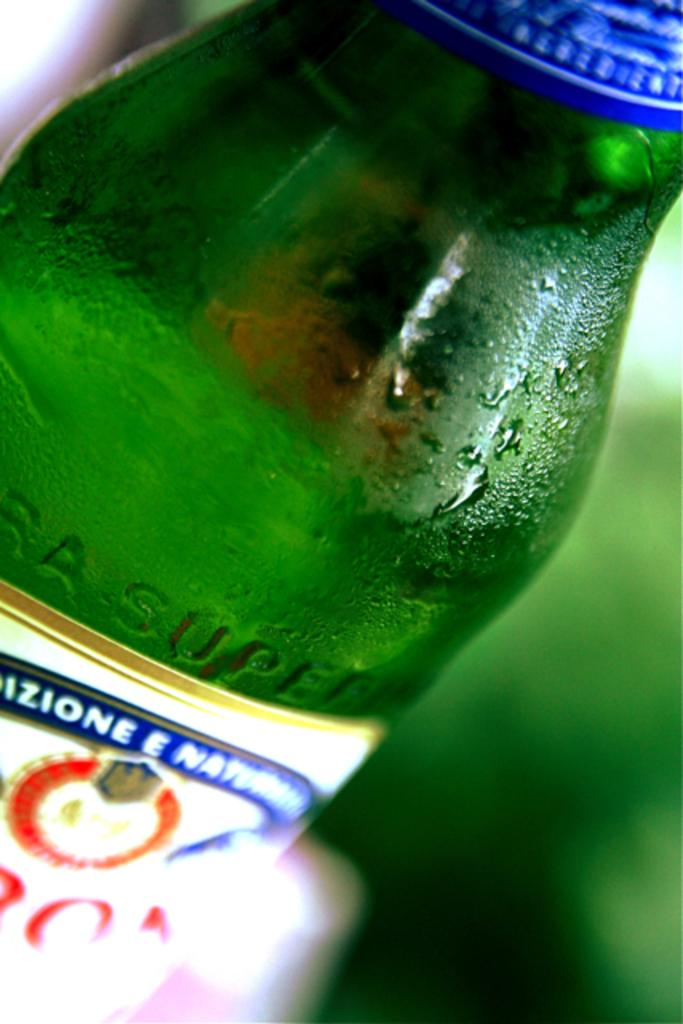What object can be seen in the image? There is a bottle in the image. How many trees are visible in the image? There are no trees visible in the image; it only features a bottle. Can you tell me the total cost of the items on the receipt in the image? There is no receipt present in the image, as it only features a bottle. 